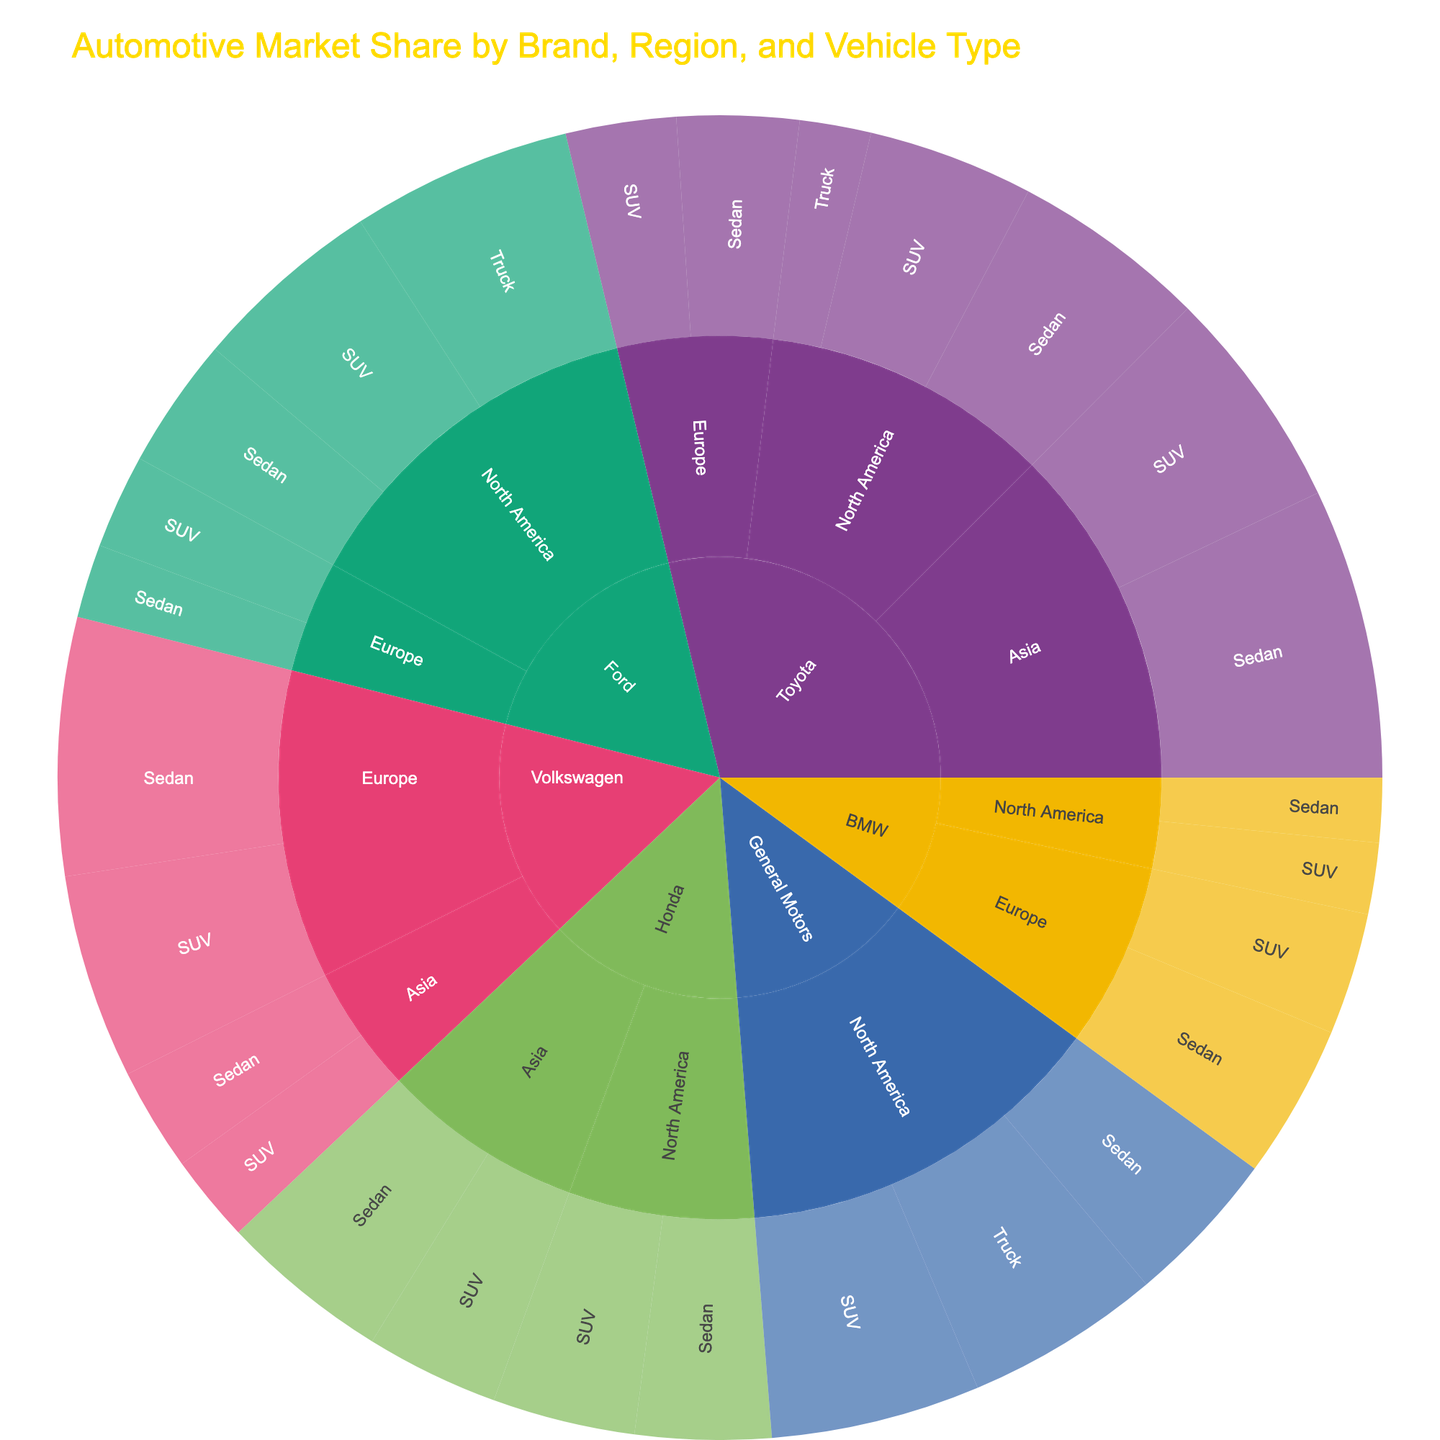How is Toyota's overall market share distributed across different regions? To find Toyota's overall market share distribution, look at the sunburst plot segment for Toyota and observe the branches expanding into North America, Europe, and Asia. Combine the market shares: 8.5% (Sedan) + 7.2% (SUV) + 3.1% (Truck) for North America, 5.3% (Sedan) + 4.8% (SUV) for Europe, and 12.6% (Sedan) + 9.7% (SUV) for Asia.
Answer: North America: 18.8%, Europe: 10.1%, Asia: 22.3% Which vehicle type has the highest market share for Ford in North America? Examine Ford's branch in the plot and check the segments for different vehicle types (Sedan, SUV, and Truck) in North America. The market shares are: Sedan (5.7%), SUV (8.3%), and Truck (9.6%).
Answer: Truck What is the total market share of Honda in Asia? Look at Honda's branch in Asia in the sunburst plot and sum the market shares of Sedan and SUV: 7.4% (Sedan) + 5.8% (SUV).
Answer: 13.2% How does Volkswagen's market share for SUVs in Europe compare to Toyota's market share for SUVs in the same region? In the sunburst plot, compare the segments for Volkswagen SUV in Europe (8.9%) with Toyota SUV in Europe (4.8%).
Answer: Volkswagen's SUV market share is higher What is the market share difference between General Motors' SUVs and Trucks in North America? For General Motors in North America, the market share is 9.1% for SUVs and 8.5% for Trucks. The difference is calculated as 9.1% - 8.5%.
Answer: 0.6% What is the combined market share of Sedans for all brands in Europe? Sum the market shares of Sedans for each brand in Europe. Toyota: 5.3%, Volkswagen: 11.2%, Ford: 3.2%, BMW: 6.7%. The combined market share is 5.3% + 11.2% + 3.2% + 6.7%.
Answer: 26.4% Which brand has the lowest market share for SUVs in North America? Analyze the sunburst plot segments for each brand's SUV market share in North America. Toyota: 7.2%, Ford: 8.3%, General Motors: 9.1%, Honda: 6.2%, BMW: 3.1%. BMW has the lowest at 3.1%.
Answer: BMW How does the market share of Trucks for Ford in North America compare to that for General Motors in the same region? In North America, Ford's Truck market share (9.6%) is compared to General Motors' Truck market share (8.5%).
Answer: Ford's Truck market share is higher What is the largest single vehicle type market share within a region for any brand? Find the highest percentage in any segment of the sunburst plot. Toyota's market share for Sedans in Asia is 12.6%, which is the largest single market share.
Answer: Toyota's Sedans in Asia: 12.6% 